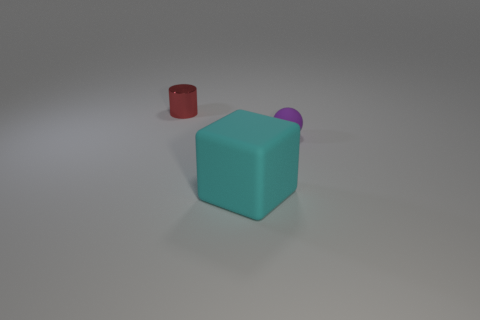There is a thing that is to the left of the tiny rubber thing and behind the big cyan object; what material is it?
Offer a very short reply. Metal. There is a purple thing; does it have the same shape as the rubber thing to the left of the purple rubber ball?
Provide a short and direct response. No. How many other things are there of the same size as the purple object?
Make the answer very short. 1. Are there more large yellow metal objects than cylinders?
Ensure brevity in your answer.  No. How many tiny things are left of the tiny purple sphere and in front of the red metal object?
Ensure brevity in your answer.  0. What shape is the small thing that is behind the small object that is in front of the object to the left of the cyan matte thing?
Your answer should be compact. Cylinder. Are there any other things that are the same shape as the cyan rubber object?
Your answer should be very brief. No. What number of spheres are large purple matte objects or cyan objects?
Give a very brief answer. 0. There is a tiny object that is to the right of the large cyan matte cube; is its color the same as the cube?
Provide a succinct answer. No. There is a object that is in front of the tiny object that is in front of the red metallic cylinder behind the cyan matte thing; what is its material?
Your response must be concise. Rubber. 